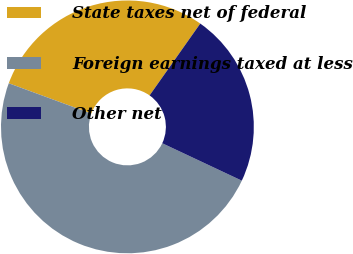Convert chart. <chart><loc_0><loc_0><loc_500><loc_500><pie_chart><fcel>State taxes net of federal<fcel>Foreign earnings taxed at less<fcel>Other net<nl><fcel>29.17%<fcel>48.61%<fcel>22.22%<nl></chart> 